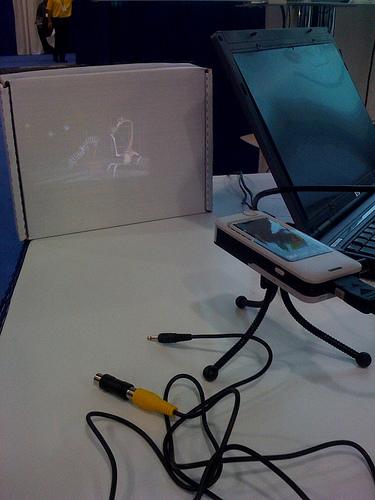Is there a laptop in the picture?
Short answer required. Yes. How many pillows are on the bed?
Short answer required. 0. Where is the image coming from?
Give a very brief answer. Phone. What is the image of?
Answer briefly. Electronics. 